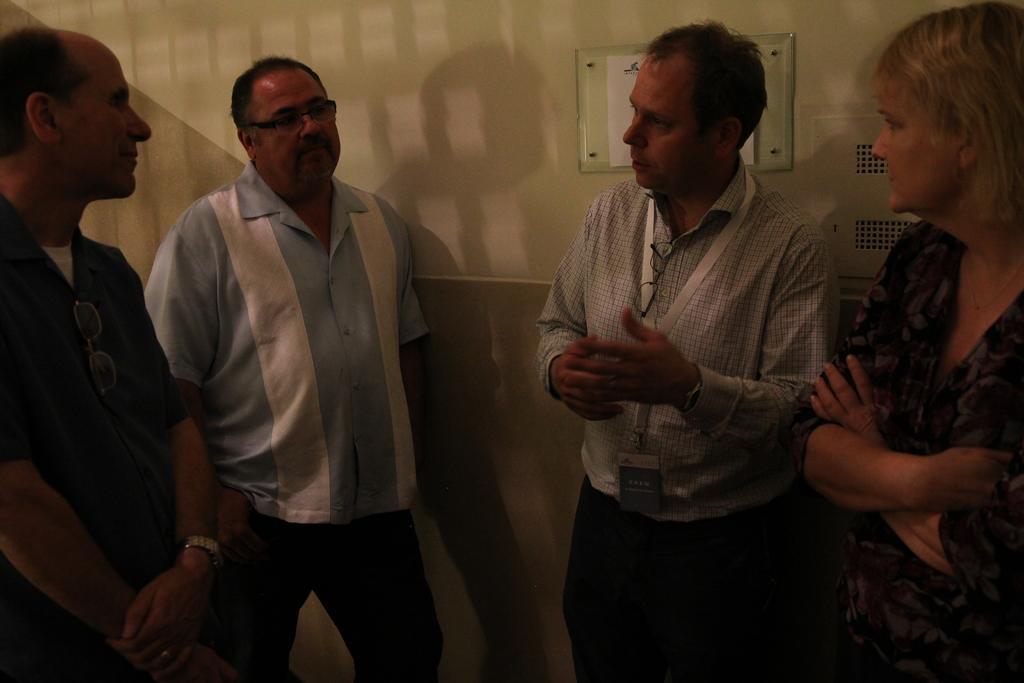How would you summarize this image in a sentence or two? In this picture we can see some group of people are standing and talking each other. 